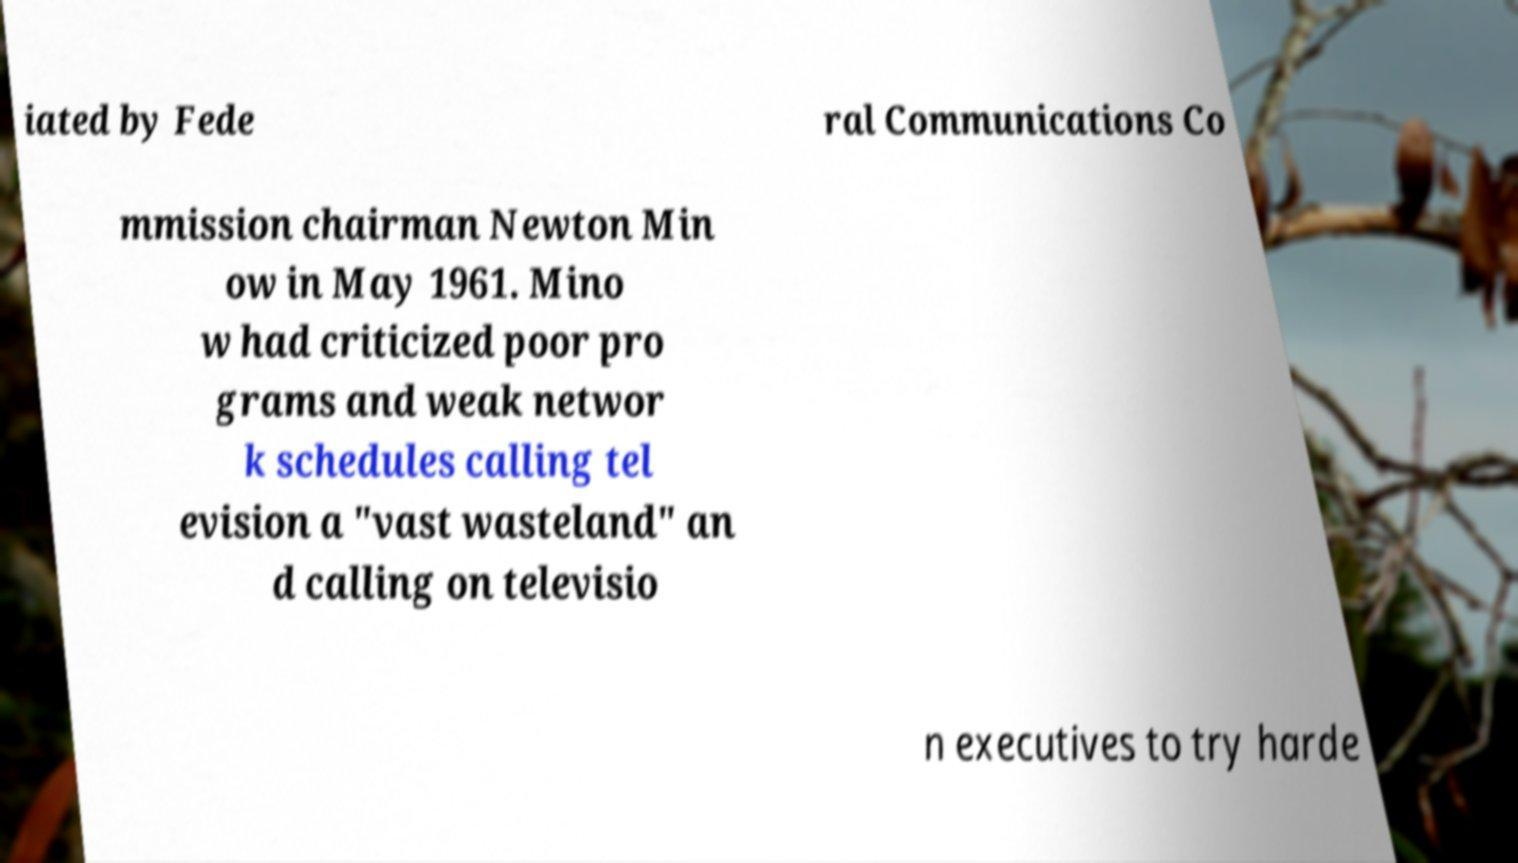Please identify and transcribe the text found in this image. iated by Fede ral Communications Co mmission chairman Newton Min ow in May 1961. Mino w had criticized poor pro grams and weak networ k schedules calling tel evision a "vast wasteland" an d calling on televisio n executives to try harde 